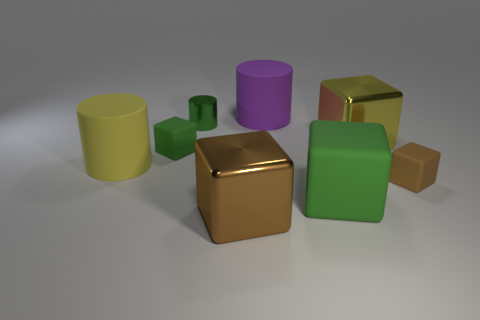Can you describe the lighting in the scene? The lighting in the scene appears to be soft and diffused, coming from the upper right-hand side, creating gentle shadows and enhancing the three-dimensional look of the objects. 